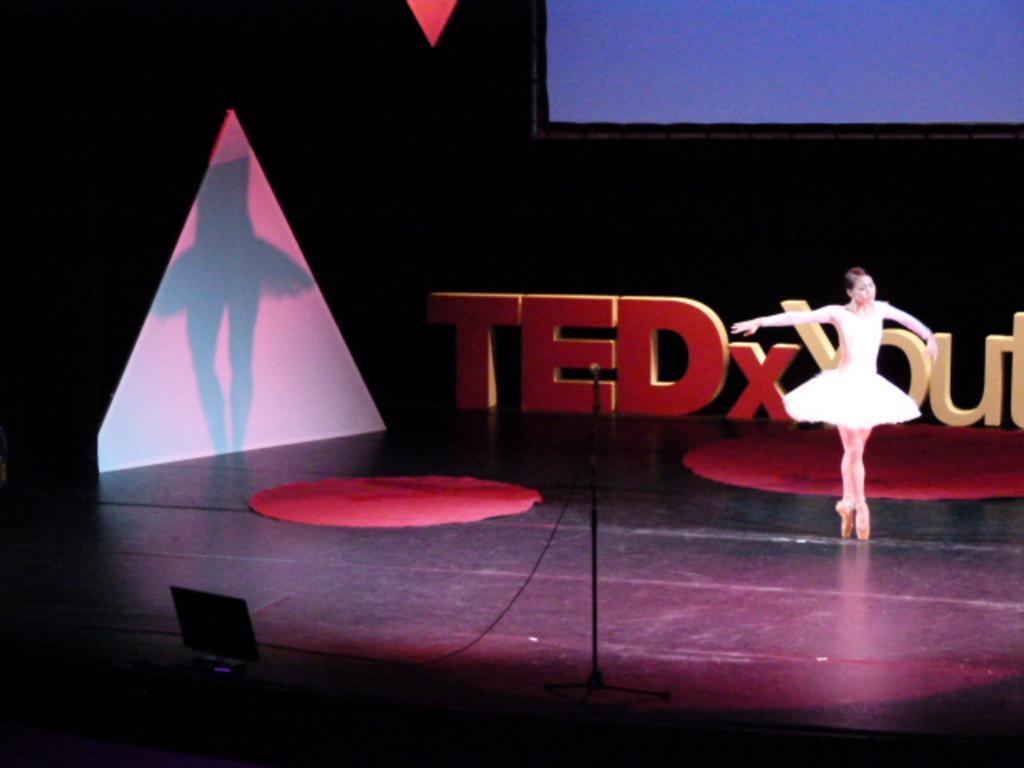Describe this image in one or two sentences. This picture is taken inside the room. In this image, on the right side, we can see a woman dancing. On the left side, we can also see a shadow of a woman. In the background, we can see a screen and some text. At the bottom, we can see a monitor, a microphone and a floor. 